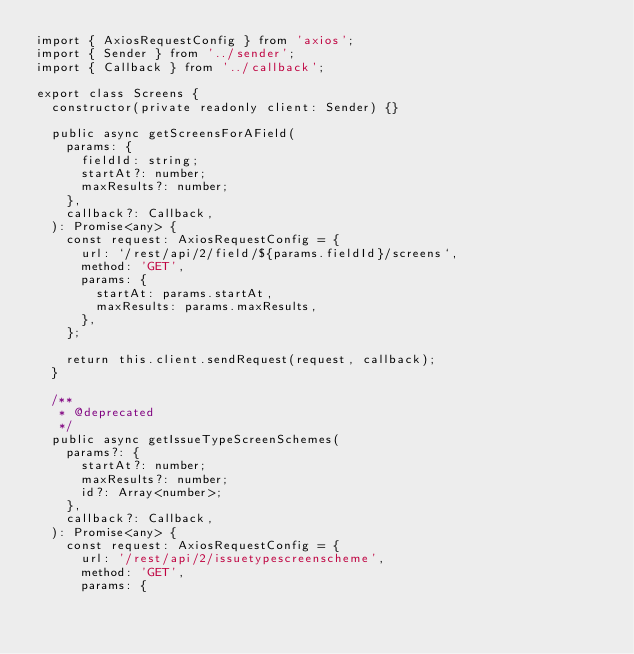<code> <loc_0><loc_0><loc_500><loc_500><_TypeScript_>import { AxiosRequestConfig } from 'axios';
import { Sender } from '../sender';
import { Callback } from '../callback';

export class Screens {
  constructor(private readonly client: Sender) {}

  public async getScreensForAField(
    params: {
      fieldId: string;
      startAt?: number;
      maxResults?: number;
    },
    callback?: Callback,
  ): Promise<any> {
    const request: AxiosRequestConfig = {
      url: `/rest/api/2/field/${params.fieldId}/screens`,
      method: 'GET',
      params: {
        startAt: params.startAt,
        maxResults: params.maxResults,
      },
    };

    return this.client.sendRequest(request, callback);
  }

  /**
   * @deprecated
   */
  public async getIssueTypeScreenSchemes(
    params?: {
      startAt?: number;
      maxResults?: number;
      id?: Array<number>;
    },
    callback?: Callback,
  ): Promise<any> {
    const request: AxiosRequestConfig = {
      url: '/rest/api/2/issuetypescreenscheme',
      method: 'GET',
      params: {</code> 